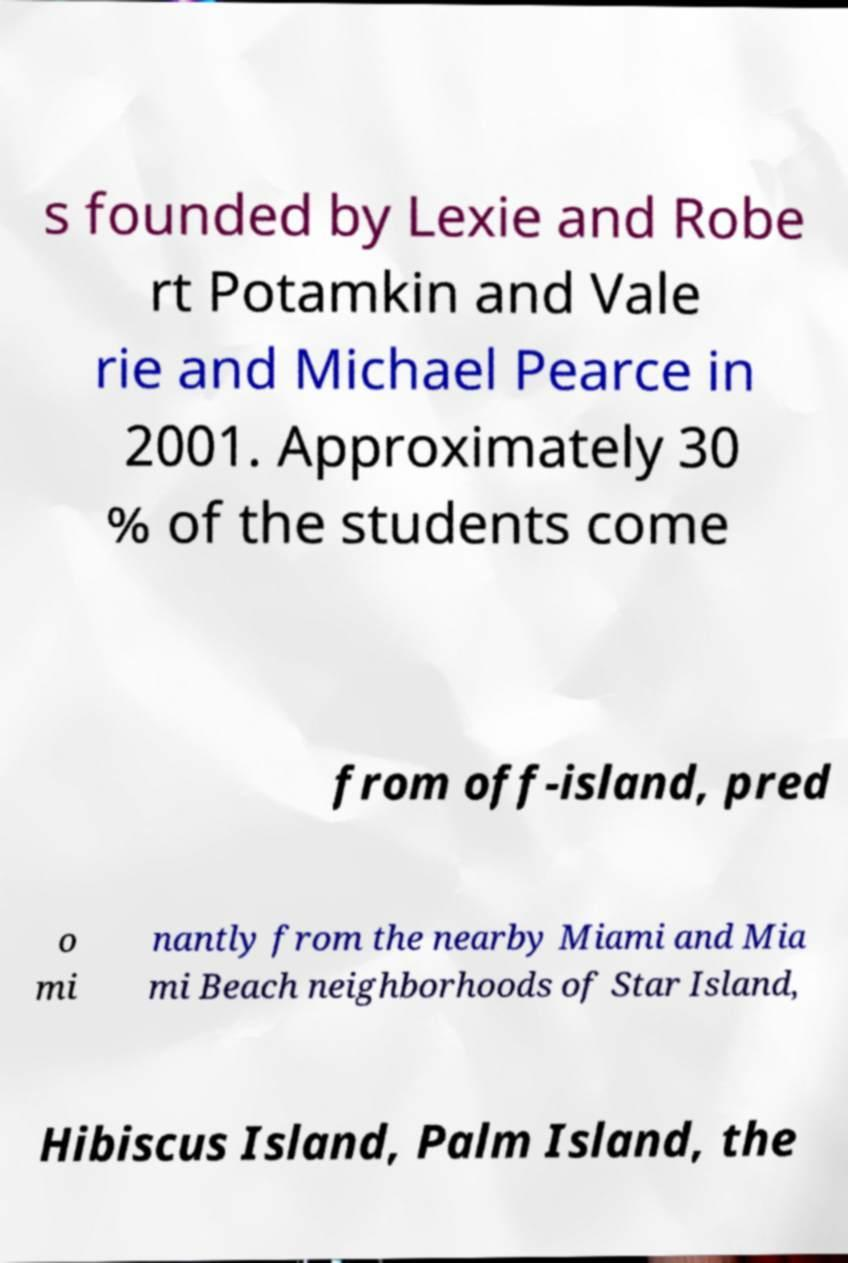Can you read and provide the text displayed in the image?This photo seems to have some interesting text. Can you extract and type it out for me? s founded by Lexie and Robe rt Potamkin and Vale rie and Michael Pearce in 2001. Approximately 30 % of the students come from off-island, pred o mi nantly from the nearby Miami and Mia mi Beach neighborhoods of Star Island, Hibiscus Island, Palm Island, the 